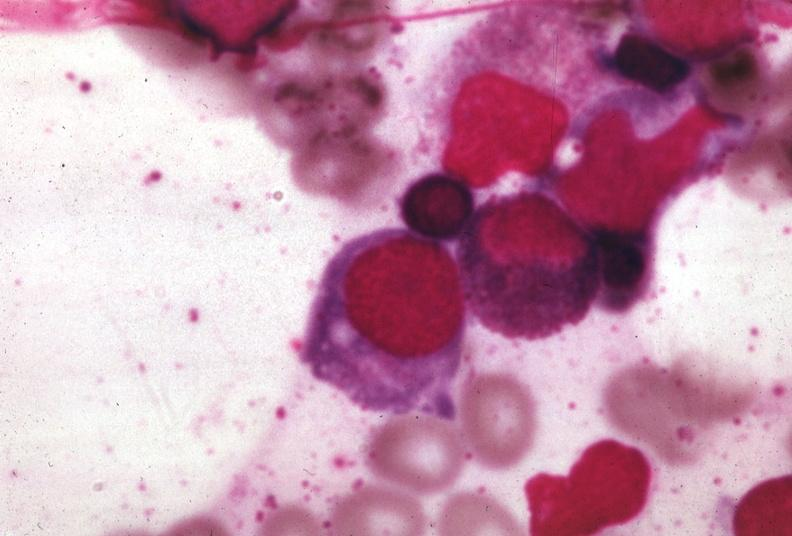s bone marrow present?
Answer the question using a single word or phrase. Yes 